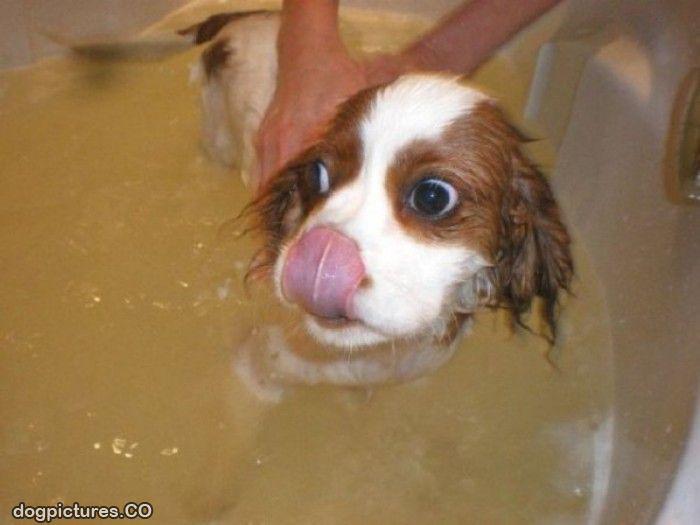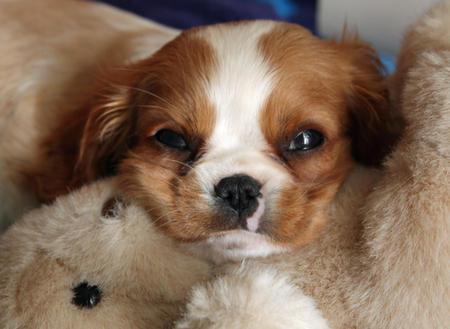The first image is the image on the left, the second image is the image on the right. For the images shown, is this caption "There are a total of exactly four dogs." true? Answer yes or no. No. 